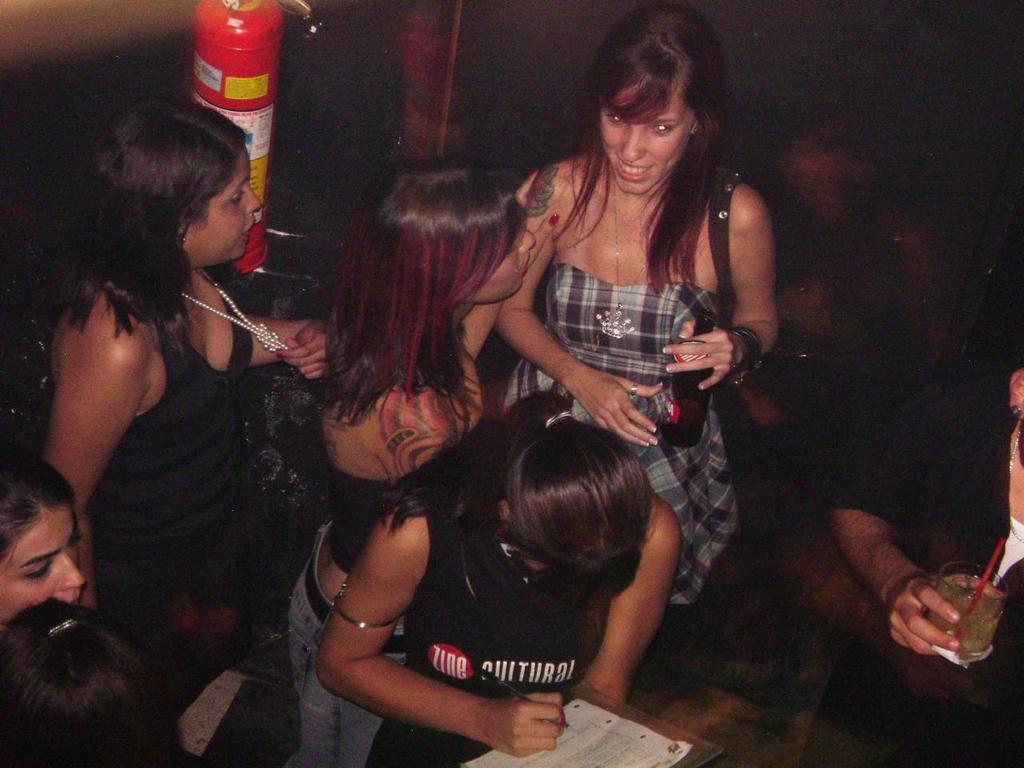How many people are in the image? There is a group of people standing in the image. Can you describe the position of the fire extinguisher in the image? The fire extinguisher is attached to the wall at the top of the image. What type of birds can be seen flying in the image? There are no birds visible in the image. What color are the roots of the trees in the image? There are no trees or roots present in the image. 